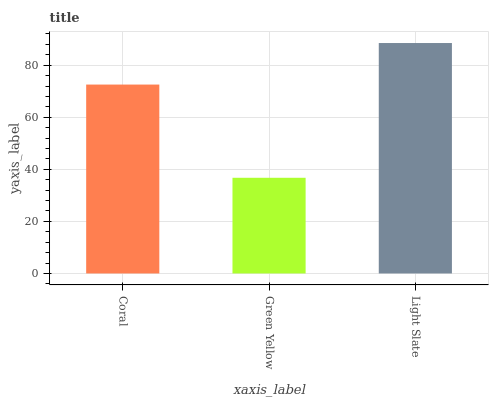Is Green Yellow the minimum?
Answer yes or no. Yes. Is Light Slate the maximum?
Answer yes or no. Yes. Is Light Slate the minimum?
Answer yes or no. No. Is Green Yellow the maximum?
Answer yes or no. No. Is Light Slate greater than Green Yellow?
Answer yes or no. Yes. Is Green Yellow less than Light Slate?
Answer yes or no. Yes. Is Green Yellow greater than Light Slate?
Answer yes or no. No. Is Light Slate less than Green Yellow?
Answer yes or no. No. Is Coral the high median?
Answer yes or no. Yes. Is Coral the low median?
Answer yes or no. Yes. Is Light Slate the high median?
Answer yes or no. No. Is Light Slate the low median?
Answer yes or no. No. 